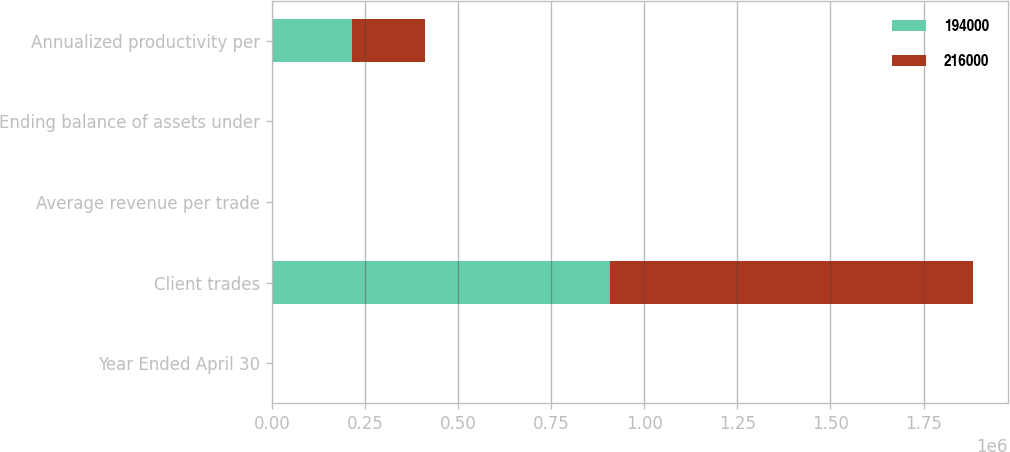Convert chart to OTSL. <chart><loc_0><loc_0><loc_500><loc_500><stacked_bar_chart><ecel><fcel>Year Ended April 30<fcel>Client trades<fcel>Average revenue per trade<fcel>Ending balance of assets under<fcel>Annualized productivity per<nl><fcel>194000<fcel>2007<fcel>907075<fcel>126.54<fcel>33.1<fcel>216000<nl><fcel>216000<fcel>2006<fcel>974625<fcel>119.11<fcel>31.8<fcel>194000<nl></chart> 